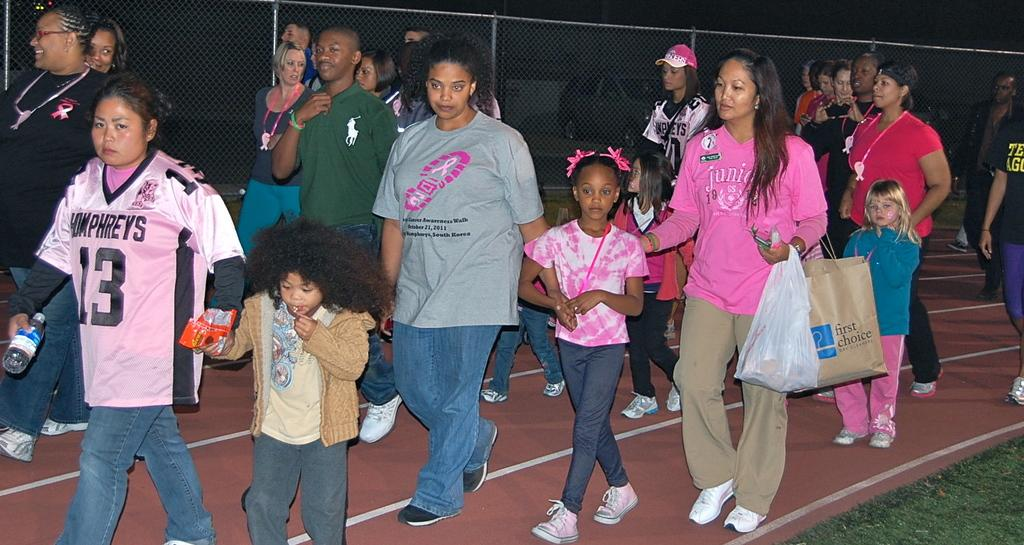Provide a one-sentence caption for the provided image. People wearing pink for charity event for breast cancer. 